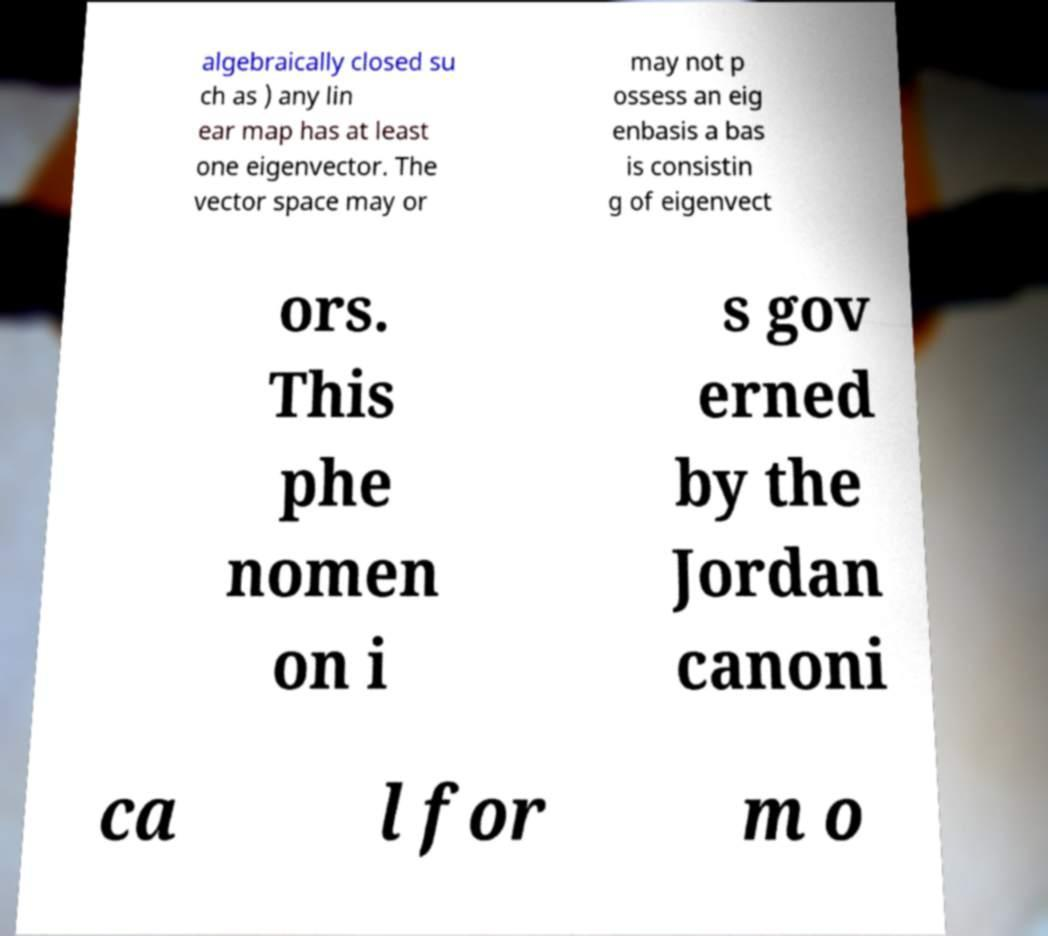There's text embedded in this image that I need extracted. Can you transcribe it verbatim? algebraically closed su ch as ) any lin ear map has at least one eigenvector. The vector space may or may not p ossess an eig enbasis a bas is consistin g of eigenvect ors. This phe nomen on i s gov erned by the Jordan canoni ca l for m o 